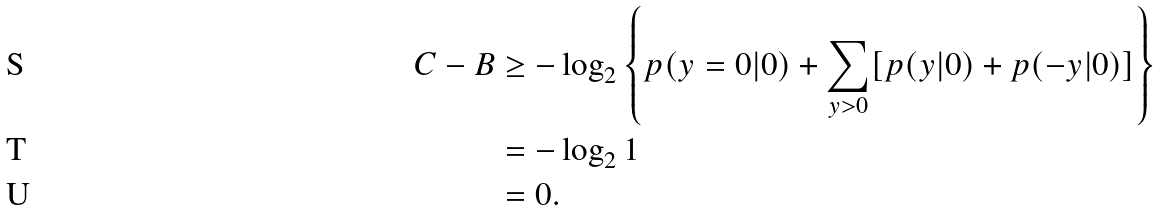<formula> <loc_0><loc_0><loc_500><loc_500>C - B & \geq - \log _ { 2 } \left \{ p ( y = 0 | 0 ) + \sum _ { y > 0 } [ p ( y | 0 ) + p ( - y | 0 ) ] \right \} \\ & = - \log _ { 2 } 1 \\ & = 0 .</formula> 